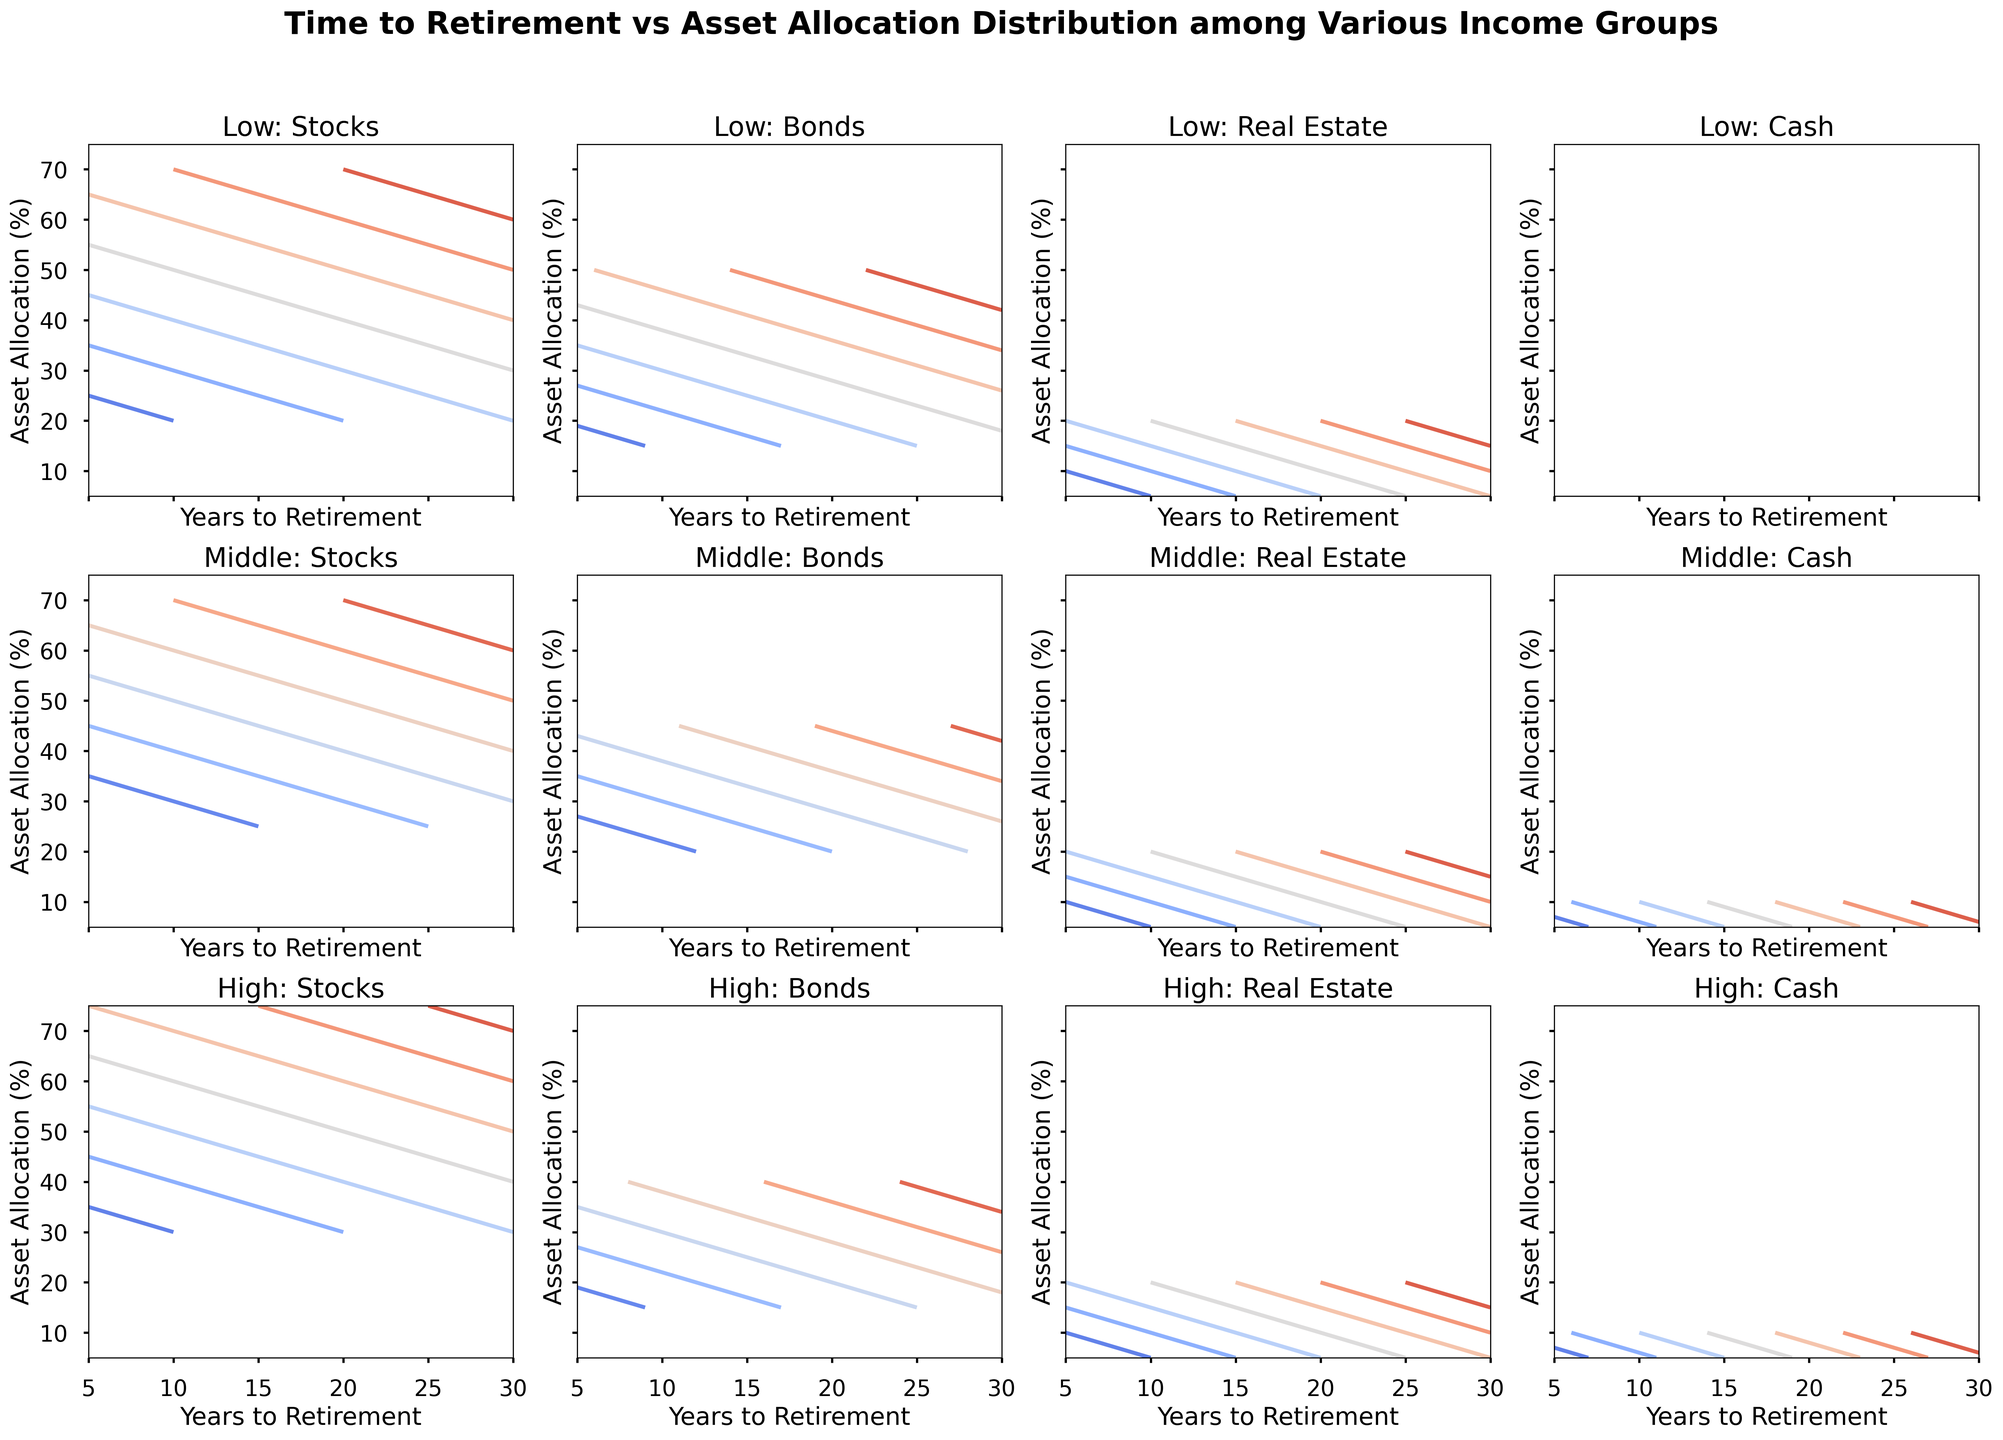what's the general trend in stock allocation as you move from 30 to 5 years to retirement for each income group? For the Low-income group, stock allocation increases from 70% to 20%. For the Middle-income group, stock allocation increases from 70% to 25%. For the High-income group, stock allocation increases from 75% to 30%. These trends are represented in the contours by the coloring shifting towards higher stock percentages closer to 5 years to retirement.
Answer: Stock allocation generally decreases as you get closer to retirement how does the bonds allocation for the low-income group at 5 years to retirement compare to the high-income group at the same point? In the contour plots, the bond allocation percentages for the Low-income group at 5 years to retirement is at 50%, while at the same point, the High-income group is at 40%.
Answer: 50% for Low-income, 40% for High-income which income group has the least variability in cash allocation across the years? By examining the contour range for cash allocation, the High-income group shows the least variability with the allocation hovering around 5%-10% over various years, compared to other income groups.
Answer: High-income group in terms of real estate allocation, how do middle-income and high-income groups differ at 20 years to retirement? For Middle-income, the real estate allocation is 15%, while for High-income, it is 10% at 20 years to retirement, as clearly indicated by the contours.
Answer: Middle-income: 15%, High-income: 10% compare the asset allocations of the middle-income group at 30 years to retirement to the low-income group at the same point. what are the differences? The Middle-income group allocates 70% to stocks, 20% to bonds, 5% to real estate, and 5% to cash. The Low-income group, in contrast, allocates 70% to stocks, 15% to bonds, 5% to real estate, and 10% to cash. The difference is the higher allocation to cash and lower allocation to bonds for Low-income groups.
Answer: Middle: 70% stocks, 20% bonds, 5% real estate, 5% cash; Low: 70% stocks, 15% bonds, 5% real estate, 10% cash what is the common trend for bonds allocation as retirement approaches across all income groups? For all income groups, the bond allocation tends to decrease as the years to retirement reduce, highlighted in the contour patterns, indicating a shift away from bonds closer to retirement.
Answer: Bond allocation decreases as retirement approaches which income group allocates the highest percentage to stocks at 25 years to retirement? At 25 years to retirement, the High-income group has the highest stock allocation at 70%, discernible from the contours in the figure.
Answer: High-income group is there any pattern observable in the real estate allocation across different income groups? Yes, real estate allocation remains relatively stable around 20% for both Low and Middle-income groups but decreases to about 10% or lower for the High-income group as the years to retirement increase.
Answer: Real Estate: stable around 20% for Low and Middle; lower for High how does the allocation to cash evolve for the middle-income group over time? For the Middle-income group, cash allocation remains constant at approximately 10% from 5 to 15 years and then drops to 5% from 20 to 30 years to retirement, as seen in the contours.
Answer: Constant at ~10%, drops to ~5% later what significant differences can be seen in asset allocation at 10 years to retirement among the different income groups? At 10 years to retirement, Low-income allocates 30% to stocks, 40% to bonds, 20% to real estate, and 10% to cash. The middle-income group allocates 35% to stocks, 35% to bonds, 20% to real estate, and 10% to cash. High-income allocates 40% to stocks, 35% to bonds, 15% to real estate, and 10% to cash. These differences are discernible in the various contours for each category.
Answer: Low: 30% stocks, 40% bonds, 20% real estate, 10% cash; Middle: 35% stocks, 35% bonds, 20% real estate, 10% cash; High: 40% stocks, 35% bonds, 15% real estate, 10% cash 